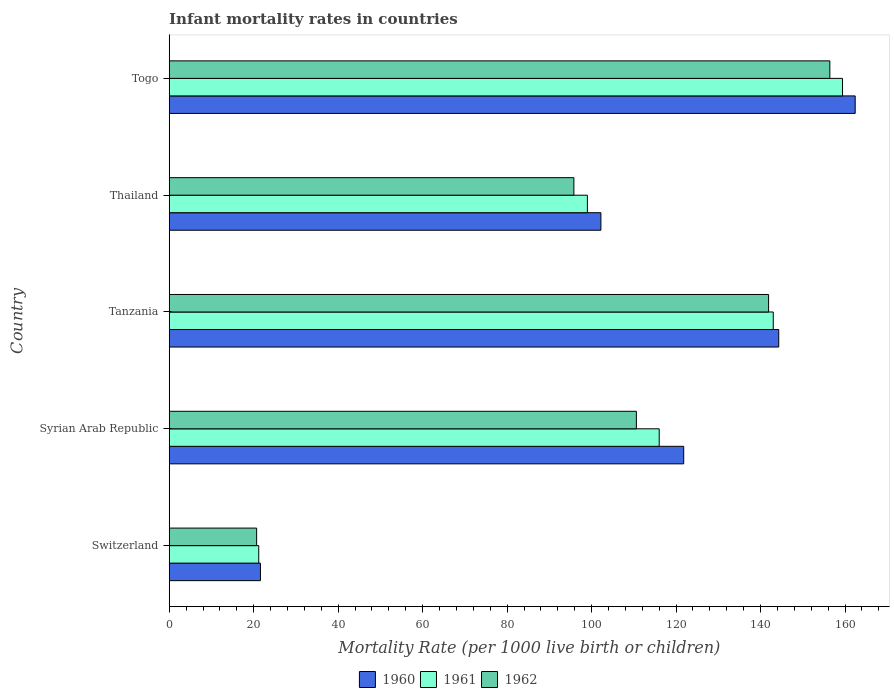How many different coloured bars are there?
Your answer should be compact. 3. Are the number of bars per tick equal to the number of legend labels?
Your answer should be very brief. Yes. What is the label of the 3rd group of bars from the top?
Offer a very short reply. Tanzania. In how many cases, is the number of bars for a given country not equal to the number of legend labels?
Ensure brevity in your answer.  0. What is the infant mortality rate in 1962 in Togo?
Give a very brief answer. 156.4. Across all countries, what is the maximum infant mortality rate in 1960?
Provide a succinct answer. 162.4. Across all countries, what is the minimum infant mortality rate in 1962?
Offer a terse response. 20.7. In which country was the infant mortality rate in 1961 maximum?
Provide a short and direct response. Togo. In which country was the infant mortality rate in 1962 minimum?
Your answer should be very brief. Switzerland. What is the total infant mortality rate in 1962 in the graph?
Ensure brevity in your answer.  525.4. What is the difference between the infant mortality rate in 1961 in Switzerland and that in Thailand?
Make the answer very short. -77.8. What is the difference between the infant mortality rate in 1961 in Thailand and the infant mortality rate in 1962 in Togo?
Your response must be concise. -57.4. What is the average infant mortality rate in 1960 per country?
Your answer should be very brief. 110.46. What is the difference between the infant mortality rate in 1961 and infant mortality rate in 1960 in Syrian Arab Republic?
Offer a very short reply. -5.8. In how many countries, is the infant mortality rate in 1961 greater than 116 ?
Provide a short and direct response. 2. What is the ratio of the infant mortality rate in 1962 in Syrian Arab Republic to that in Thailand?
Provide a succinct answer. 1.15. Is the difference between the infant mortality rate in 1961 in Tanzania and Togo greater than the difference between the infant mortality rate in 1960 in Tanzania and Togo?
Keep it short and to the point. Yes. What is the difference between the highest and the second highest infant mortality rate in 1960?
Ensure brevity in your answer.  18.1. What is the difference between the highest and the lowest infant mortality rate in 1962?
Ensure brevity in your answer.  135.7. In how many countries, is the infant mortality rate in 1961 greater than the average infant mortality rate in 1961 taken over all countries?
Your response must be concise. 3. Is the sum of the infant mortality rate in 1960 in Tanzania and Togo greater than the maximum infant mortality rate in 1961 across all countries?
Your response must be concise. Yes. What does the 1st bar from the top in Syrian Arab Republic represents?
Offer a very short reply. 1962. What does the 2nd bar from the bottom in Togo represents?
Keep it short and to the point. 1961. How many bars are there?
Provide a short and direct response. 15. Are all the bars in the graph horizontal?
Provide a succinct answer. Yes. What is the difference between two consecutive major ticks on the X-axis?
Offer a terse response. 20. Does the graph contain any zero values?
Keep it short and to the point. No. How many legend labels are there?
Make the answer very short. 3. What is the title of the graph?
Provide a short and direct response. Infant mortality rates in countries. What is the label or title of the X-axis?
Keep it short and to the point. Mortality Rate (per 1000 live birth or children). What is the Mortality Rate (per 1000 live birth or children) of 1960 in Switzerland?
Provide a succinct answer. 21.6. What is the Mortality Rate (per 1000 live birth or children) in 1961 in Switzerland?
Keep it short and to the point. 21.2. What is the Mortality Rate (per 1000 live birth or children) in 1962 in Switzerland?
Offer a very short reply. 20.7. What is the Mortality Rate (per 1000 live birth or children) of 1960 in Syrian Arab Republic?
Offer a terse response. 121.8. What is the Mortality Rate (per 1000 live birth or children) in 1961 in Syrian Arab Republic?
Offer a very short reply. 116. What is the Mortality Rate (per 1000 live birth or children) of 1962 in Syrian Arab Republic?
Offer a very short reply. 110.6. What is the Mortality Rate (per 1000 live birth or children) in 1960 in Tanzania?
Make the answer very short. 144.3. What is the Mortality Rate (per 1000 live birth or children) of 1961 in Tanzania?
Offer a very short reply. 143. What is the Mortality Rate (per 1000 live birth or children) in 1962 in Tanzania?
Make the answer very short. 141.9. What is the Mortality Rate (per 1000 live birth or children) in 1960 in Thailand?
Offer a terse response. 102.2. What is the Mortality Rate (per 1000 live birth or children) of 1962 in Thailand?
Provide a succinct answer. 95.8. What is the Mortality Rate (per 1000 live birth or children) in 1960 in Togo?
Offer a terse response. 162.4. What is the Mortality Rate (per 1000 live birth or children) in 1961 in Togo?
Your answer should be very brief. 159.4. What is the Mortality Rate (per 1000 live birth or children) of 1962 in Togo?
Provide a succinct answer. 156.4. Across all countries, what is the maximum Mortality Rate (per 1000 live birth or children) in 1960?
Make the answer very short. 162.4. Across all countries, what is the maximum Mortality Rate (per 1000 live birth or children) of 1961?
Make the answer very short. 159.4. Across all countries, what is the maximum Mortality Rate (per 1000 live birth or children) in 1962?
Provide a short and direct response. 156.4. Across all countries, what is the minimum Mortality Rate (per 1000 live birth or children) in 1960?
Give a very brief answer. 21.6. Across all countries, what is the minimum Mortality Rate (per 1000 live birth or children) of 1961?
Your answer should be very brief. 21.2. Across all countries, what is the minimum Mortality Rate (per 1000 live birth or children) in 1962?
Offer a very short reply. 20.7. What is the total Mortality Rate (per 1000 live birth or children) in 1960 in the graph?
Keep it short and to the point. 552.3. What is the total Mortality Rate (per 1000 live birth or children) in 1961 in the graph?
Make the answer very short. 538.6. What is the total Mortality Rate (per 1000 live birth or children) of 1962 in the graph?
Your response must be concise. 525.4. What is the difference between the Mortality Rate (per 1000 live birth or children) in 1960 in Switzerland and that in Syrian Arab Republic?
Give a very brief answer. -100.2. What is the difference between the Mortality Rate (per 1000 live birth or children) of 1961 in Switzerland and that in Syrian Arab Republic?
Offer a terse response. -94.8. What is the difference between the Mortality Rate (per 1000 live birth or children) of 1962 in Switzerland and that in Syrian Arab Republic?
Offer a terse response. -89.9. What is the difference between the Mortality Rate (per 1000 live birth or children) in 1960 in Switzerland and that in Tanzania?
Give a very brief answer. -122.7. What is the difference between the Mortality Rate (per 1000 live birth or children) of 1961 in Switzerland and that in Tanzania?
Offer a very short reply. -121.8. What is the difference between the Mortality Rate (per 1000 live birth or children) in 1962 in Switzerland and that in Tanzania?
Your response must be concise. -121.2. What is the difference between the Mortality Rate (per 1000 live birth or children) of 1960 in Switzerland and that in Thailand?
Your response must be concise. -80.6. What is the difference between the Mortality Rate (per 1000 live birth or children) in 1961 in Switzerland and that in Thailand?
Ensure brevity in your answer.  -77.8. What is the difference between the Mortality Rate (per 1000 live birth or children) in 1962 in Switzerland and that in Thailand?
Ensure brevity in your answer.  -75.1. What is the difference between the Mortality Rate (per 1000 live birth or children) in 1960 in Switzerland and that in Togo?
Make the answer very short. -140.8. What is the difference between the Mortality Rate (per 1000 live birth or children) of 1961 in Switzerland and that in Togo?
Give a very brief answer. -138.2. What is the difference between the Mortality Rate (per 1000 live birth or children) of 1962 in Switzerland and that in Togo?
Provide a succinct answer. -135.7. What is the difference between the Mortality Rate (per 1000 live birth or children) in 1960 in Syrian Arab Republic and that in Tanzania?
Keep it short and to the point. -22.5. What is the difference between the Mortality Rate (per 1000 live birth or children) of 1961 in Syrian Arab Republic and that in Tanzania?
Offer a very short reply. -27. What is the difference between the Mortality Rate (per 1000 live birth or children) of 1962 in Syrian Arab Republic and that in Tanzania?
Your response must be concise. -31.3. What is the difference between the Mortality Rate (per 1000 live birth or children) in 1960 in Syrian Arab Republic and that in Thailand?
Offer a very short reply. 19.6. What is the difference between the Mortality Rate (per 1000 live birth or children) of 1962 in Syrian Arab Republic and that in Thailand?
Make the answer very short. 14.8. What is the difference between the Mortality Rate (per 1000 live birth or children) in 1960 in Syrian Arab Republic and that in Togo?
Keep it short and to the point. -40.6. What is the difference between the Mortality Rate (per 1000 live birth or children) in 1961 in Syrian Arab Republic and that in Togo?
Give a very brief answer. -43.4. What is the difference between the Mortality Rate (per 1000 live birth or children) in 1962 in Syrian Arab Republic and that in Togo?
Make the answer very short. -45.8. What is the difference between the Mortality Rate (per 1000 live birth or children) in 1960 in Tanzania and that in Thailand?
Your answer should be compact. 42.1. What is the difference between the Mortality Rate (per 1000 live birth or children) of 1962 in Tanzania and that in Thailand?
Offer a very short reply. 46.1. What is the difference between the Mortality Rate (per 1000 live birth or children) of 1960 in Tanzania and that in Togo?
Your answer should be compact. -18.1. What is the difference between the Mortality Rate (per 1000 live birth or children) in 1961 in Tanzania and that in Togo?
Offer a terse response. -16.4. What is the difference between the Mortality Rate (per 1000 live birth or children) in 1960 in Thailand and that in Togo?
Provide a short and direct response. -60.2. What is the difference between the Mortality Rate (per 1000 live birth or children) in 1961 in Thailand and that in Togo?
Your response must be concise. -60.4. What is the difference between the Mortality Rate (per 1000 live birth or children) in 1962 in Thailand and that in Togo?
Offer a terse response. -60.6. What is the difference between the Mortality Rate (per 1000 live birth or children) of 1960 in Switzerland and the Mortality Rate (per 1000 live birth or children) of 1961 in Syrian Arab Republic?
Ensure brevity in your answer.  -94.4. What is the difference between the Mortality Rate (per 1000 live birth or children) in 1960 in Switzerland and the Mortality Rate (per 1000 live birth or children) in 1962 in Syrian Arab Republic?
Provide a short and direct response. -89. What is the difference between the Mortality Rate (per 1000 live birth or children) of 1961 in Switzerland and the Mortality Rate (per 1000 live birth or children) of 1962 in Syrian Arab Republic?
Keep it short and to the point. -89.4. What is the difference between the Mortality Rate (per 1000 live birth or children) in 1960 in Switzerland and the Mortality Rate (per 1000 live birth or children) in 1961 in Tanzania?
Ensure brevity in your answer.  -121.4. What is the difference between the Mortality Rate (per 1000 live birth or children) of 1960 in Switzerland and the Mortality Rate (per 1000 live birth or children) of 1962 in Tanzania?
Your answer should be very brief. -120.3. What is the difference between the Mortality Rate (per 1000 live birth or children) in 1961 in Switzerland and the Mortality Rate (per 1000 live birth or children) in 1962 in Tanzania?
Offer a terse response. -120.7. What is the difference between the Mortality Rate (per 1000 live birth or children) of 1960 in Switzerland and the Mortality Rate (per 1000 live birth or children) of 1961 in Thailand?
Give a very brief answer. -77.4. What is the difference between the Mortality Rate (per 1000 live birth or children) in 1960 in Switzerland and the Mortality Rate (per 1000 live birth or children) in 1962 in Thailand?
Offer a very short reply. -74.2. What is the difference between the Mortality Rate (per 1000 live birth or children) of 1961 in Switzerland and the Mortality Rate (per 1000 live birth or children) of 1962 in Thailand?
Provide a succinct answer. -74.6. What is the difference between the Mortality Rate (per 1000 live birth or children) of 1960 in Switzerland and the Mortality Rate (per 1000 live birth or children) of 1961 in Togo?
Your answer should be compact. -137.8. What is the difference between the Mortality Rate (per 1000 live birth or children) of 1960 in Switzerland and the Mortality Rate (per 1000 live birth or children) of 1962 in Togo?
Offer a very short reply. -134.8. What is the difference between the Mortality Rate (per 1000 live birth or children) in 1961 in Switzerland and the Mortality Rate (per 1000 live birth or children) in 1962 in Togo?
Your answer should be compact. -135.2. What is the difference between the Mortality Rate (per 1000 live birth or children) of 1960 in Syrian Arab Republic and the Mortality Rate (per 1000 live birth or children) of 1961 in Tanzania?
Give a very brief answer. -21.2. What is the difference between the Mortality Rate (per 1000 live birth or children) in 1960 in Syrian Arab Republic and the Mortality Rate (per 1000 live birth or children) in 1962 in Tanzania?
Offer a very short reply. -20.1. What is the difference between the Mortality Rate (per 1000 live birth or children) of 1961 in Syrian Arab Republic and the Mortality Rate (per 1000 live birth or children) of 1962 in Tanzania?
Make the answer very short. -25.9. What is the difference between the Mortality Rate (per 1000 live birth or children) in 1960 in Syrian Arab Republic and the Mortality Rate (per 1000 live birth or children) in 1961 in Thailand?
Your response must be concise. 22.8. What is the difference between the Mortality Rate (per 1000 live birth or children) in 1961 in Syrian Arab Republic and the Mortality Rate (per 1000 live birth or children) in 1962 in Thailand?
Your response must be concise. 20.2. What is the difference between the Mortality Rate (per 1000 live birth or children) in 1960 in Syrian Arab Republic and the Mortality Rate (per 1000 live birth or children) in 1961 in Togo?
Your response must be concise. -37.6. What is the difference between the Mortality Rate (per 1000 live birth or children) in 1960 in Syrian Arab Republic and the Mortality Rate (per 1000 live birth or children) in 1962 in Togo?
Ensure brevity in your answer.  -34.6. What is the difference between the Mortality Rate (per 1000 live birth or children) in 1961 in Syrian Arab Republic and the Mortality Rate (per 1000 live birth or children) in 1962 in Togo?
Your answer should be compact. -40.4. What is the difference between the Mortality Rate (per 1000 live birth or children) of 1960 in Tanzania and the Mortality Rate (per 1000 live birth or children) of 1961 in Thailand?
Ensure brevity in your answer.  45.3. What is the difference between the Mortality Rate (per 1000 live birth or children) of 1960 in Tanzania and the Mortality Rate (per 1000 live birth or children) of 1962 in Thailand?
Provide a succinct answer. 48.5. What is the difference between the Mortality Rate (per 1000 live birth or children) of 1961 in Tanzania and the Mortality Rate (per 1000 live birth or children) of 1962 in Thailand?
Provide a succinct answer. 47.2. What is the difference between the Mortality Rate (per 1000 live birth or children) of 1960 in Tanzania and the Mortality Rate (per 1000 live birth or children) of 1961 in Togo?
Give a very brief answer. -15.1. What is the difference between the Mortality Rate (per 1000 live birth or children) in 1960 in Thailand and the Mortality Rate (per 1000 live birth or children) in 1961 in Togo?
Your response must be concise. -57.2. What is the difference between the Mortality Rate (per 1000 live birth or children) of 1960 in Thailand and the Mortality Rate (per 1000 live birth or children) of 1962 in Togo?
Offer a terse response. -54.2. What is the difference between the Mortality Rate (per 1000 live birth or children) in 1961 in Thailand and the Mortality Rate (per 1000 live birth or children) in 1962 in Togo?
Your response must be concise. -57.4. What is the average Mortality Rate (per 1000 live birth or children) in 1960 per country?
Offer a very short reply. 110.46. What is the average Mortality Rate (per 1000 live birth or children) of 1961 per country?
Make the answer very short. 107.72. What is the average Mortality Rate (per 1000 live birth or children) in 1962 per country?
Offer a terse response. 105.08. What is the difference between the Mortality Rate (per 1000 live birth or children) of 1960 and Mortality Rate (per 1000 live birth or children) of 1961 in Syrian Arab Republic?
Give a very brief answer. 5.8. What is the difference between the Mortality Rate (per 1000 live birth or children) of 1960 and Mortality Rate (per 1000 live birth or children) of 1962 in Syrian Arab Republic?
Give a very brief answer. 11.2. What is the difference between the Mortality Rate (per 1000 live birth or children) of 1961 and Mortality Rate (per 1000 live birth or children) of 1962 in Syrian Arab Republic?
Ensure brevity in your answer.  5.4. What is the difference between the Mortality Rate (per 1000 live birth or children) in 1960 and Mortality Rate (per 1000 live birth or children) in 1961 in Tanzania?
Keep it short and to the point. 1.3. What is the difference between the Mortality Rate (per 1000 live birth or children) in 1960 and Mortality Rate (per 1000 live birth or children) in 1962 in Thailand?
Ensure brevity in your answer.  6.4. What is the difference between the Mortality Rate (per 1000 live birth or children) in 1960 and Mortality Rate (per 1000 live birth or children) in 1962 in Togo?
Make the answer very short. 6. What is the difference between the Mortality Rate (per 1000 live birth or children) in 1961 and Mortality Rate (per 1000 live birth or children) in 1962 in Togo?
Offer a very short reply. 3. What is the ratio of the Mortality Rate (per 1000 live birth or children) in 1960 in Switzerland to that in Syrian Arab Republic?
Ensure brevity in your answer.  0.18. What is the ratio of the Mortality Rate (per 1000 live birth or children) in 1961 in Switzerland to that in Syrian Arab Republic?
Keep it short and to the point. 0.18. What is the ratio of the Mortality Rate (per 1000 live birth or children) of 1962 in Switzerland to that in Syrian Arab Republic?
Give a very brief answer. 0.19. What is the ratio of the Mortality Rate (per 1000 live birth or children) in 1960 in Switzerland to that in Tanzania?
Keep it short and to the point. 0.15. What is the ratio of the Mortality Rate (per 1000 live birth or children) in 1961 in Switzerland to that in Tanzania?
Provide a short and direct response. 0.15. What is the ratio of the Mortality Rate (per 1000 live birth or children) in 1962 in Switzerland to that in Tanzania?
Your answer should be very brief. 0.15. What is the ratio of the Mortality Rate (per 1000 live birth or children) of 1960 in Switzerland to that in Thailand?
Give a very brief answer. 0.21. What is the ratio of the Mortality Rate (per 1000 live birth or children) of 1961 in Switzerland to that in Thailand?
Your answer should be very brief. 0.21. What is the ratio of the Mortality Rate (per 1000 live birth or children) of 1962 in Switzerland to that in Thailand?
Give a very brief answer. 0.22. What is the ratio of the Mortality Rate (per 1000 live birth or children) in 1960 in Switzerland to that in Togo?
Provide a short and direct response. 0.13. What is the ratio of the Mortality Rate (per 1000 live birth or children) in 1961 in Switzerland to that in Togo?
Your response must be concise. 0.13. What is the ratio of the Mortality Rate (per 1000 live birth or children) of 1962 in Switzerland to that in Togo?
Offer a terse response. 0.13. What is the ratio of the Mortality Rate (per 1000 live birth or children) in 1960 in Syrian Arab Republic to that in Tanzania?
Provide a short and direct response. 0.84. What is the ratio of the Mortality Rate (per 1000 live birth or children) of 1961 in Syrian Arab Republic to that in Tanzania?
Offer a terse response. 0.81. What is the ratio of the Mortality Rate (per 1000 live birth or children) in 1962 in Syrian Arab Republic to that in Tanzania?
Keep it short and to the point. 0.78. What is the ratio of the Mortality Rate (per 1000 live birth or children) of 1960 in Syrian Arab Republic to that in Thailand?
Keep it short and to the point. 1.19. What is the ratio of the Mortality Rate (per 1000 live birth or children) in 1961 in Syrian Arab Republic to that in Thailand?
Keep it short and to the point. 1.17. What is the ratio of the Mortality Rate (per 1000 live birth or children) of 1962 in Syrian Arab Republic to that in Thailand?
Keep it short and to the point. 1.15. What is the ratio of the Mortality Rate (per 1000 live birth or children) of 1961 in Syrian Arab Republic to that in Togo?
Give a very brief answer. 0.73. What is the ratio of the Mortality Rate (per 1000 live birth or children) in 1962 in Syrian Arab Republic to that in Togo?
Your answer should be very brief. 0.71. What is the ratio of the Mortality Rate (per 1000 live birth or children) in 1960 in Tanzania to that in Thailand?
Your answer should be compact. 1.41. What is the ratio of the Mortality Rate (per 1000 live birth or children) in 1961 in Tanzania to that in Thailand?
Keep it short and to the point. 1.44. What is the ratio of the Mortality Rate (per 1000 live birth or children) in 1962 in Tanzania to that in Thailand?
Offer a terse response. 1.48. What is the ratio of the Mortality Rate (per 1000 live birth or children) in 1960 in Tanzania to that in Togo?
Your answer should be very brief. 0.89. What is the ratio of the Mortality Rate (per 1000 live birth or children) in 1961 in Tanzania to that in Togo?
Your answer should be compact. 0.9. What is the ratio of the Mortality Rate (per 1000 live birth or children) of 1962 in Tanzania to that in Togo?
Offer a very short reply. 0.91. What is the ratio of the Mortality Rate (per 1000 live birth or children) of 1960 in Thailand to that in Togo?
Provide a succinct answer. 0.63. What is the ratio of the Mortality Rate (per 1000 live birth or children) of 1961 in Thailand to that in Togo?
Make the answer very short. 0.62. What is the ratio of the Mortality Rate (per 1000 live birth or children) of 1962 in Thailand to that in Togo?
Keep it short and to the point. 0.61. What is the difference between the highest and the second highest Mortality Rate (per 1000 live birth or children) of 1960?
Offer a terse response. 18.1. What is the difference between the highest and the second highest Mortality Rate (per 1000 live birth or children) of 1962?
Provide a succinct answer. 14.5. What is the difference between the highest and the lowest Mortality Rate (per 1000 live birth or children) of 1960?
Your answer should be very brief. 140.8. What is the difference between the highest and the lowest Mortality Rate (per 1000 live birth or children) in 1961?
Your response must be concise. 138.2. What is the difference between the highest and the lowest Mortality Rate (per 1000 live birth or children) in 1962?
Offer a terse response. 135.7. 